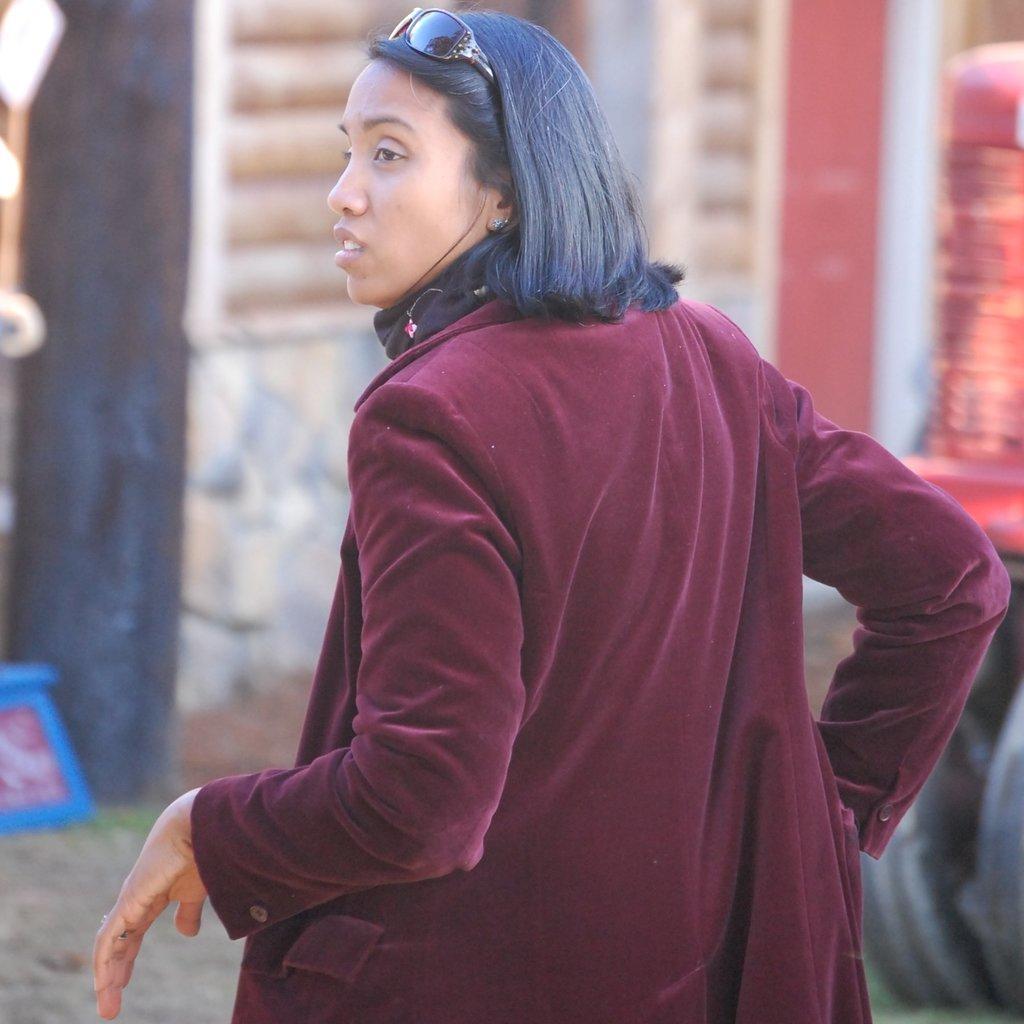Please provide a concise description of this image. In this picture we can see a woman with the goggles. In front of the women there are some blurred objects. 